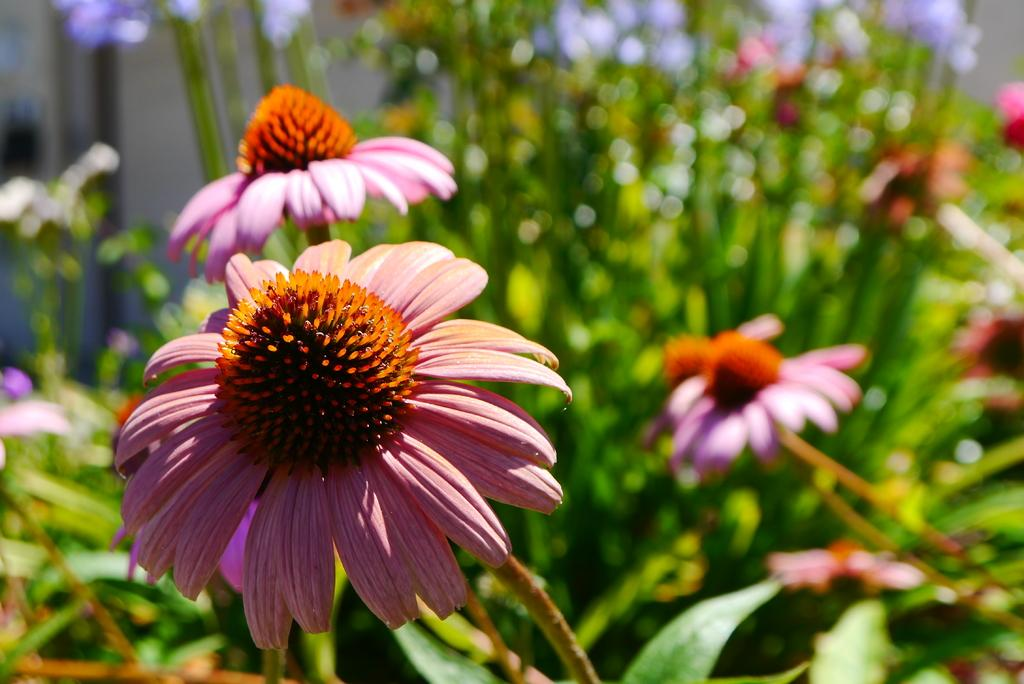What type of plants are present in the image? There are floral plants in the image. Can you describe the background of the image? The background of the image is blurred. What language is spoken by the soap in the image? There is no soap present in the image, and therefore no language can be attributed to it. 